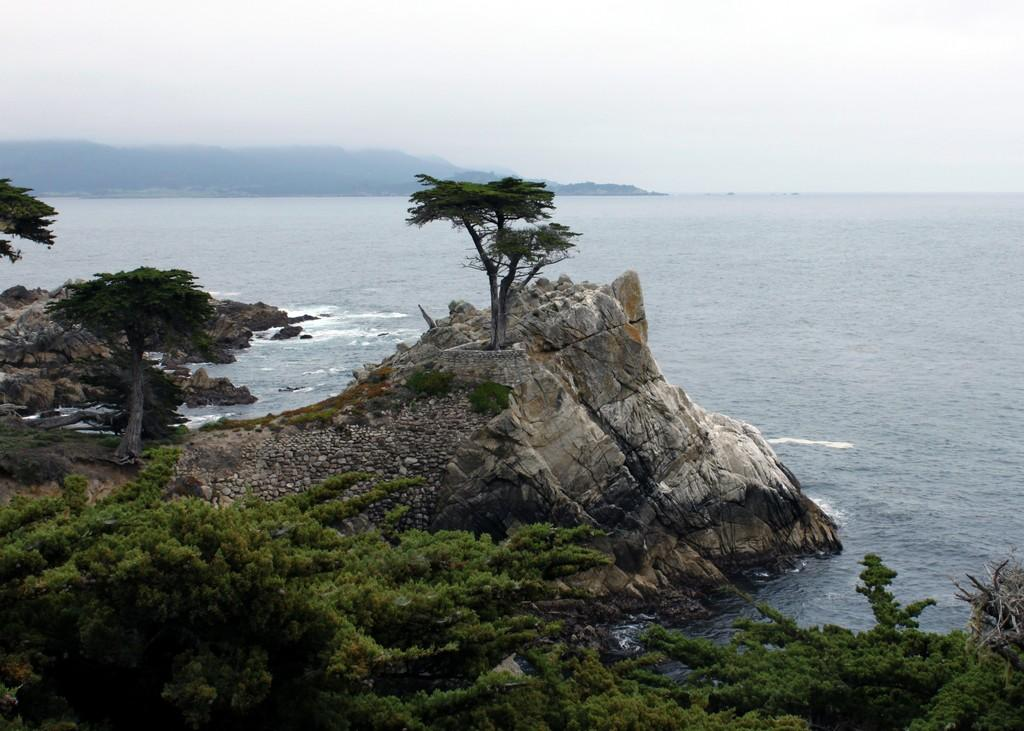What type of vegetation can be seen in the image? There are trees in the image. What natural feature is visible in the image? There is water visible in the image. What geographical feature can be seen in the image? There are hills in the image. What is visible at the top of the image? The sky is visible at the top of the image. How many carts are visible in the image? There are no carts present in the image. What type of group can be seen interacting with the water in the image? There is no group present in the image; it features trees, water, hills, and the sky. 